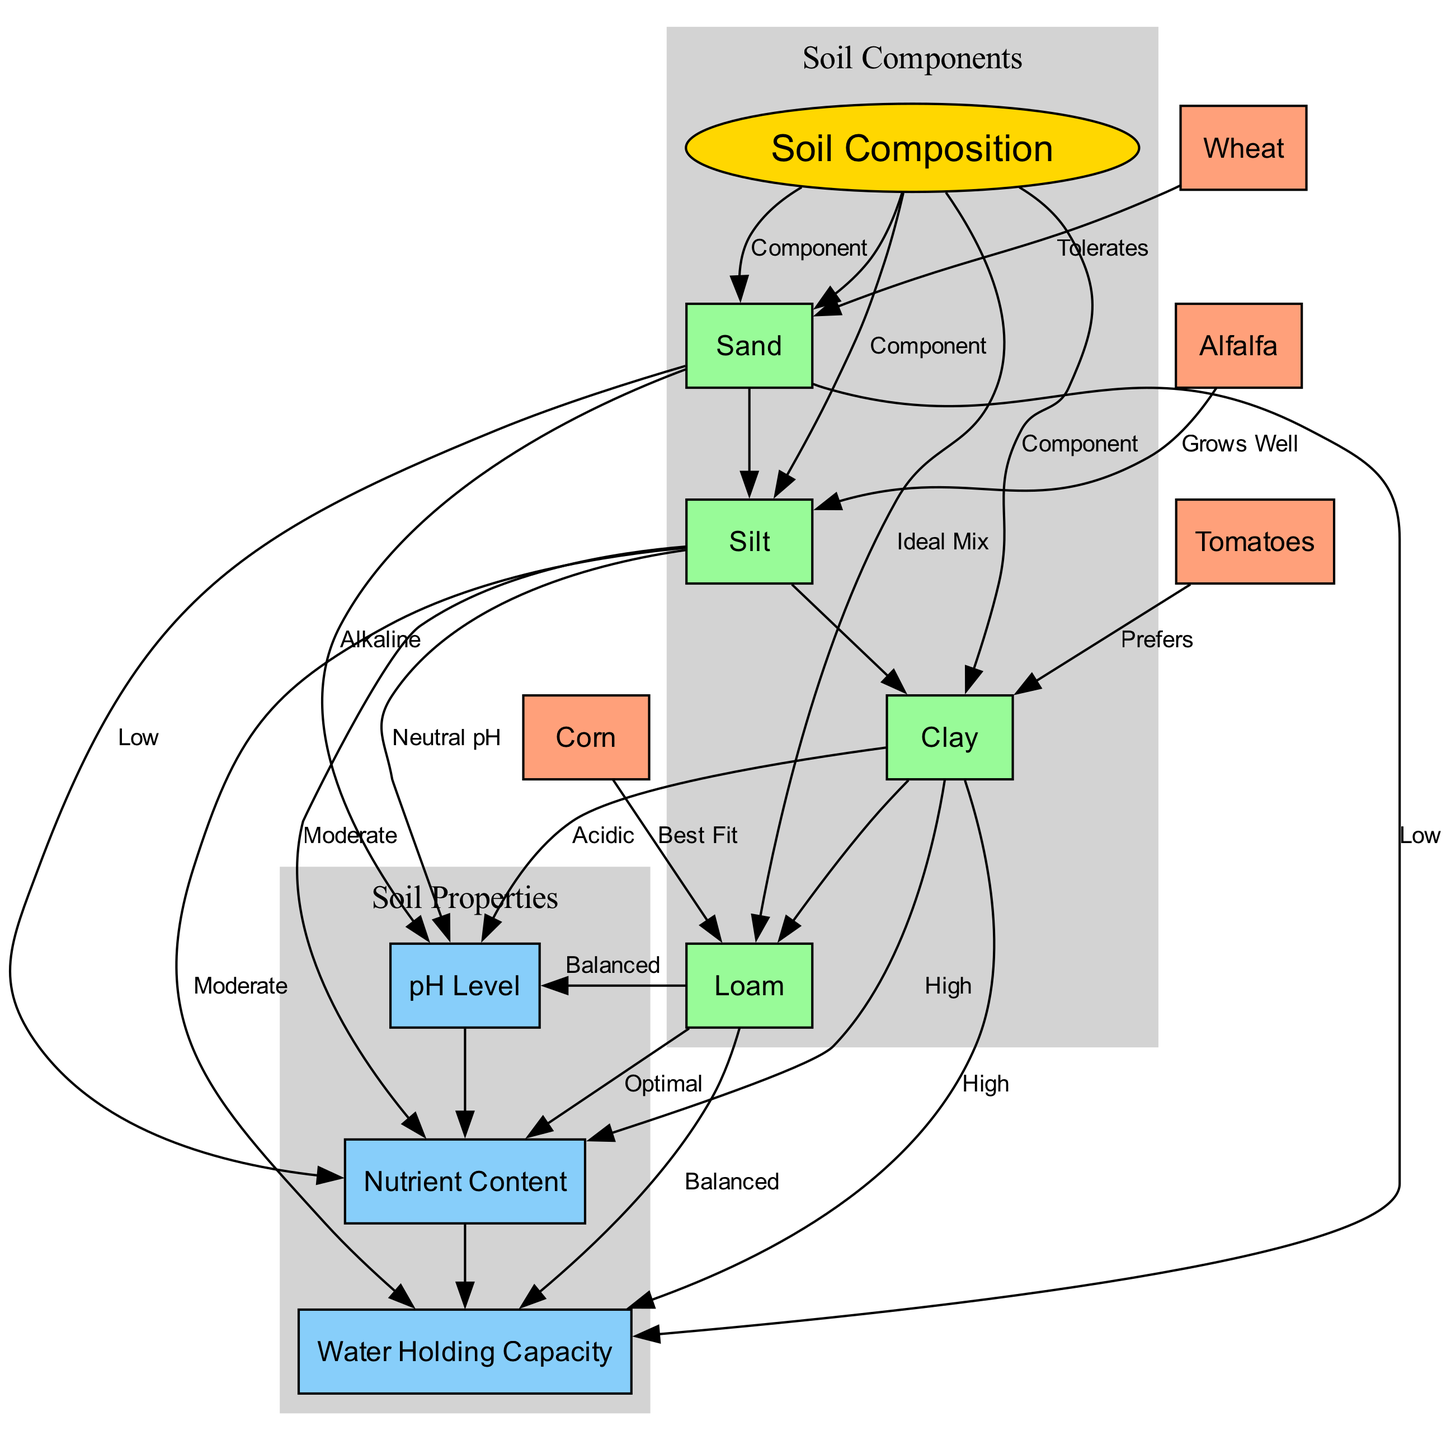What are the components of soil composition? The diagram shows four main components of soil composition, which are sand, silt, clay, and loam. Each component is represented by a node linked to the main node "Soil Composition."
Answer: Sand, silt, clay, loam Which type of soil has the highest nutrient content? The diagram indicates that clay soil has the highest nutrient content, as per the relationship between clay and nutrient content in the edges.
Answer: High What is the ideal soil mix for corn? According to the diagram, loam is labeled as the best fit for corn, showing the relationship between corn and the ideal soil composition.
Answer: Best Fit What type of pH level does clay soil prefer? The diagram illustrates that clay soil is associated with acidic pH levels based on the connection made in the edges.
Answer: Acidic Which crop grows well in silt soil? The diagram states that alfalfa grows well in silt soil, indicated by the connection between alfalfa and silt.
Answer: Grows Well Which soil type has low water holding capacity? The diagram shows that sand has a low water holding capacity, based on the relationship drawn between sand and water holding capacity.
Answer: Low How many nodes represent different types of crops? By counting the nodes corresponding to the crops in the diagram, it is evident that there are four crop nodes represented: corn, tomatoes, wheat, and alfalfa.
Answer: Four What type of soil do tomatoes prefer? The diagram specifically indicates that tomatoes prefer clay soil as shown in the edge representing their relationship.
Answer: Prefers What is the relationship between loam and pH level? The diagram describes the relationship by stating that loam has a balanced pH level, indicating its optimal condition as depicted in the edge.
Answer: Balanced 